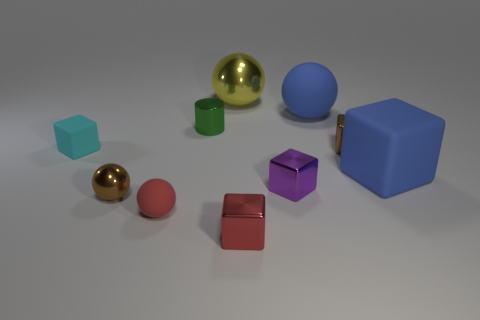Is there anything else that is the same shape as the yellow object?
Ensure brevity in your answer.  Yes. What material is the cube that is the same color as the large rubber sphere?
Ensure brevity in your answer.  Rubber. There is a small rubber thing that is to the left of the brown shiny thing that is on the left side of the yellow metallic object; what number of blue matte spheres are in front of it?
Ensure brevity in your answer.  0. There is a cyan matte block; how many purple metal things are on the left side of it?
Offer a very short reply. 0. How many tiny blue balls are made of the same material as the small purple block?
Your answer should be compact. 0. What color is the big block that is made of the same material as the tiny cyan block?
Your answer should be compact. Blue. What material is the large blue object behind the tiny object on the left side of the tiny brown thing left of the large metallic thing made of?
Ensure brevity in your answer.  Rubber. There is a blue sphere behind the green metallic thing; is it the same size as the blue rubber block?
Ensure brevity in your answer.  Yes. What number of large things are blue matte things or rubber objects?
Your answer should be very brief. 2. Is there a big shiny ball of the same color as the cylinder?
Offer a very short reply. No. 